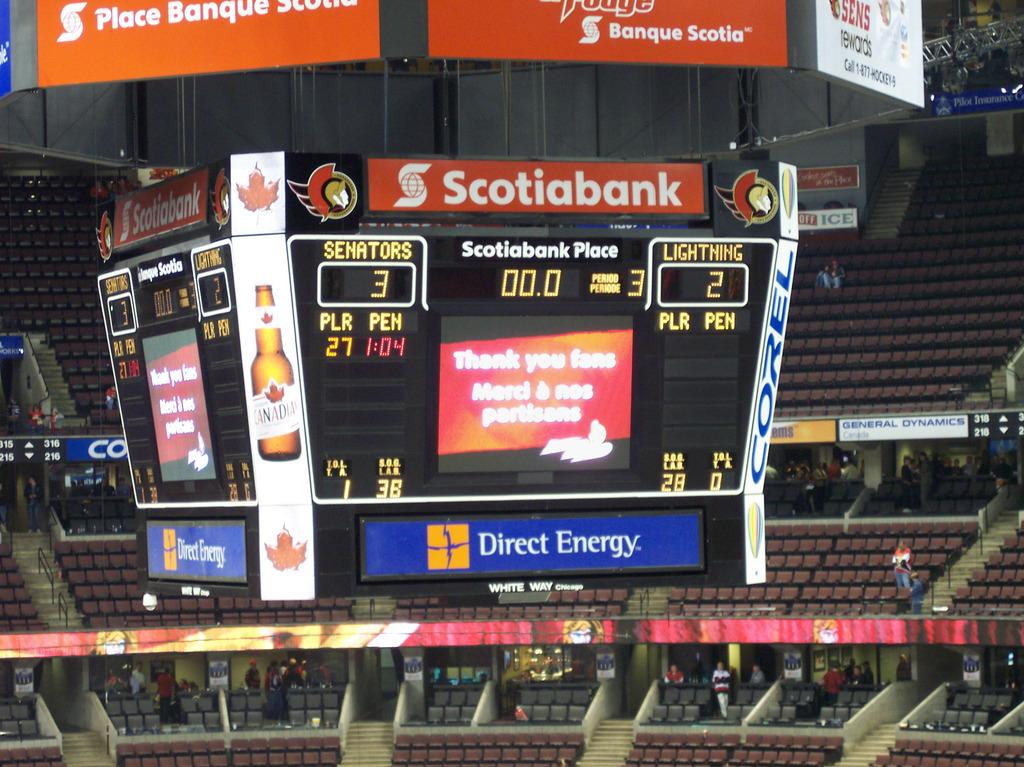<image>
Create a compact narrative representing the image presented. A stadium scoreboard displays advertisements for Direct Energy, Scotiabank, and Corel. 